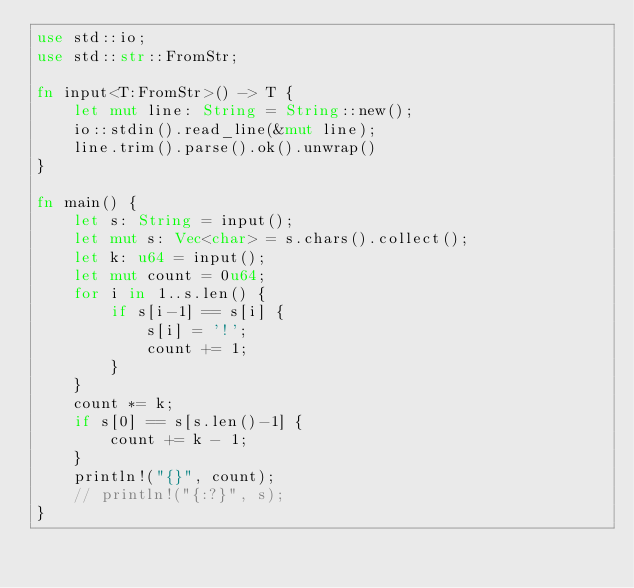Convert code to text. <code><loc_0><loc_0><loc_500><loc_500><_Rust_>use std::io;
use std::str::FromStr;

fn input<T:FromStr>() -> T {
    let mut line: String = String::new();
    io::stdin().read_line(&mut line);
    line.trim().parse().ok().unwrap()
}

fn main() {
    let s: String = input();
    let mut s: Vec<char> = s.chars().collect();
    let k: u64 = input();
    let mut count = 0u64;
    for i in 1..s.len() {
        if s[i-1] == s[i] {
            s[i] = '!';
            count += 1;
        }
    }
    count *= k;
    if s[0] == s[s.len()-1] {
        count += k - 1;
    }
    println!("{}", count);
    // println!("{:?}", s);
}
</code> 